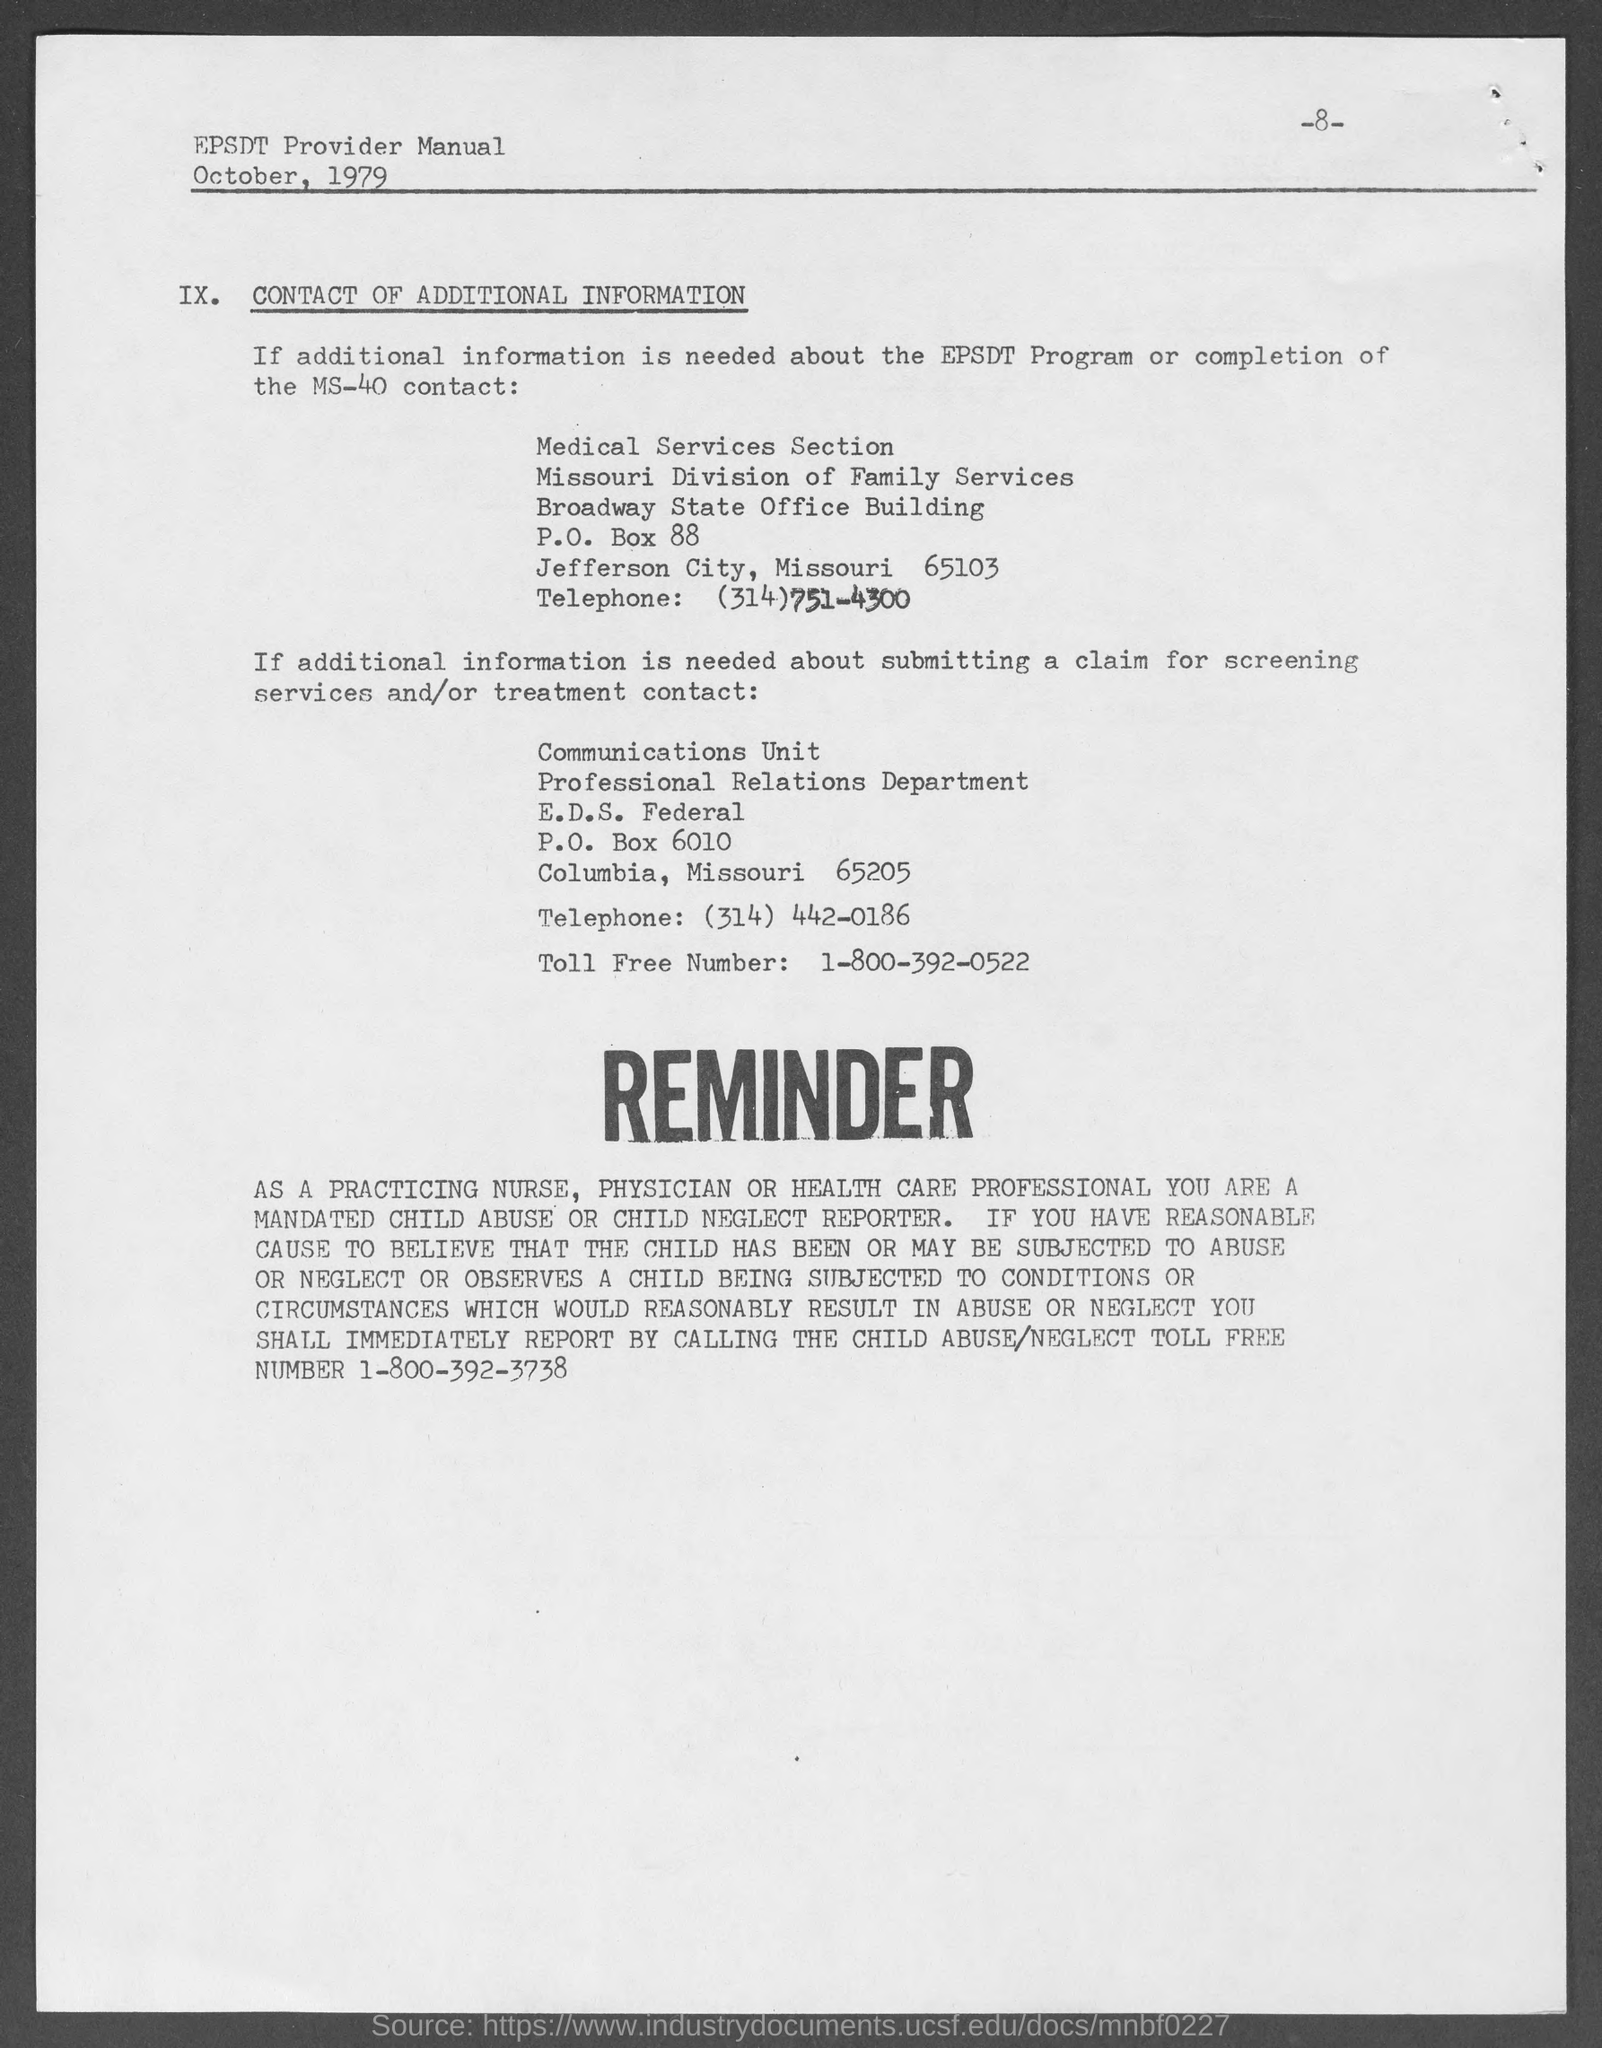What is the page number at top of the page?
Provide a short and direct response. 8. What is p.o number of professional relations department ?
Your answer should be compact. 6010. What is the p.o box no. of medical services section ?
Your response must be concise. 88. What is the building name of medical services section ?
Offer a terse response. Broadway State Office Building. What is the telephone number of medical services section ?
Provide a short and direct response. (314) 751-4300. What is the telephone number of professional relations department ?
Your answer should be compact. (314) 442-0186. What is the toll free number of professional relations department ?
Give a very brief answer. 1-800-392-0522. What is the toll free number for child abuse/ neglect ?
Your answer should be very brief. 1-800-392-3738. 